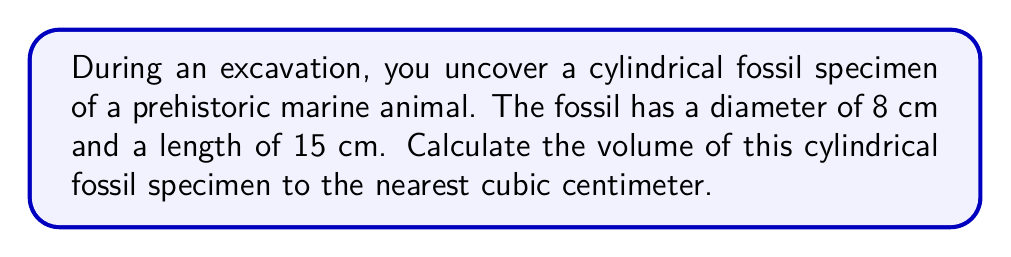What is the answer to this math problem? To calculate the volume of a cylindrical fossil specimen, we need to use the formula for the volume of a cylinder:

$$V = \pi r^2 h$$

Where:
$V$ = volume
$r$ = radius of the base
$h$ = height (length) of the cylinder

Given:
- Diameter = 8 cm
- Length = 15 cm

Step 1: Calculate the radius
The radius is half the diameter:
$r = \frac{8}{2} = 4$ cm

Step 2: Substitute the values into the formula
$$V = \pi (4\text{ cm})^2 (15\text{ cm})$$

Step 3: Calculate
$$\begin{align*}
V &= \pi (16\text{ cm}^2) (15\text{ cm}) \\
&= 240\pi\text{ cm}^3 \\
&\approx 753.98\text{ cm}^3
\end{align*}$$

Step 4: Round to the nearest cubic centimeter
$753.98\text{ cm}^3 \approx 754\text{ cm}^3$

[asy]
import geometry;

size(200);
real r = 4;
real h = 15;

path base = circle((0,0), r);
path top = circle((0,h), r);

draw(base);
draw(top);
draw((r,0)--(r,h));
draw((-r,0)--(-r,h));
draw((0,0)--(0,h), dashed);

label("r", (r/2,0), E);
label("h", (r,h/2), E);

draw((0,0)--(r,0), Arrow);
draw((r,0)--(r,h), Arrow);
[/asy]
Answer: $754\text{ cm}^3$ 